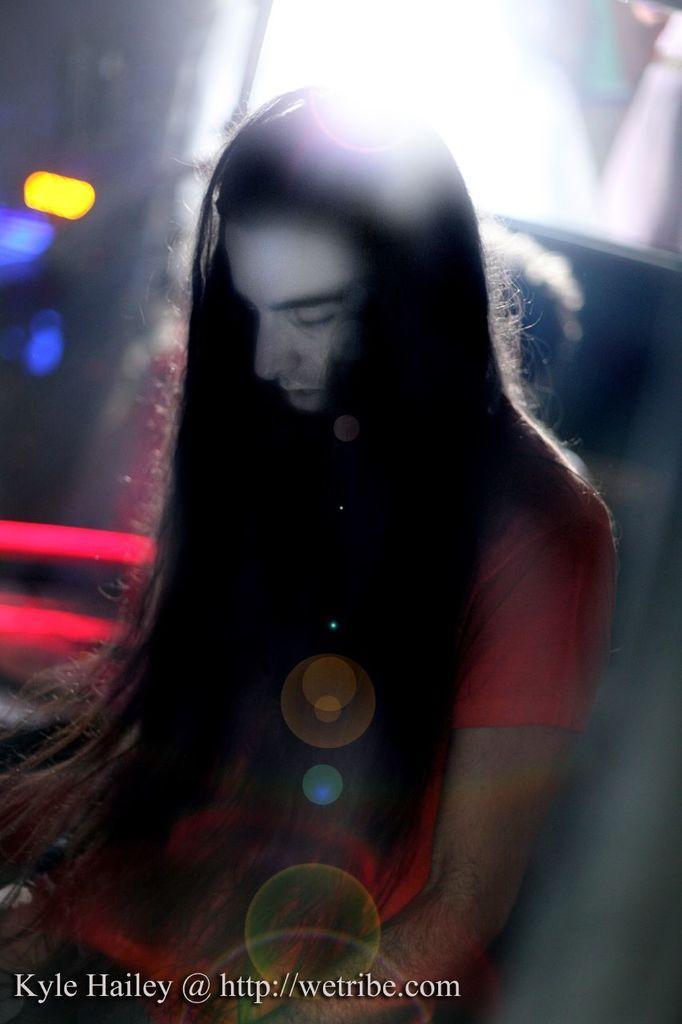Can you describe this image briefly? It is an edited image. In this image we can see a man with long hair. We can also see the lights and in the bottom left corner we can see the text. 